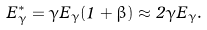Convert formula to latex. <formula><loc_0><loc_0><loc_500><loc_500>E ^ { * } _ { \gamma } = \gamma E _ { \gamma } ( 1 + \beta ) \approx 2 \gamma E _ { \gamma } .</formula> 